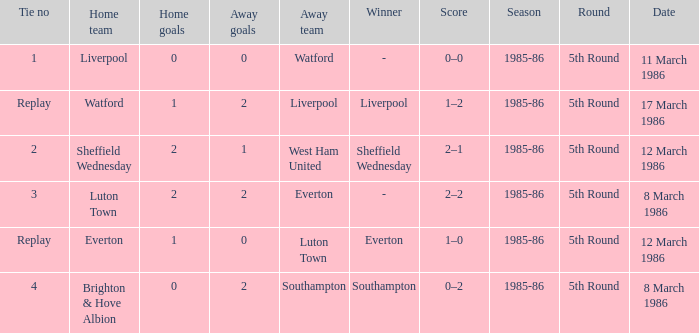Who was the home team in the match against Luton Town? Everton. 